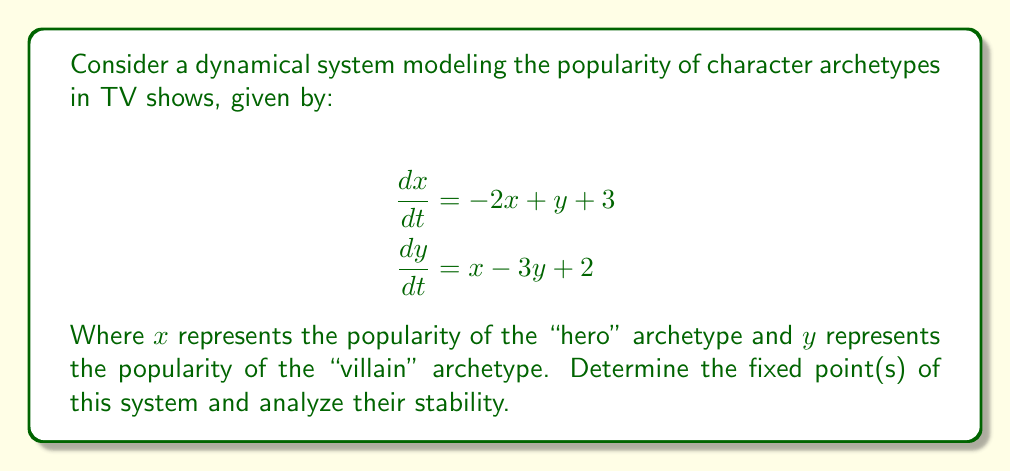Show me your answer to this math problem. 1. To find the fixed points, set both equations equal to zero:
   $$-2x + y + 3 = 0$$
   $$x - 3y + 2 = 0$$

2. Solve this system of equations:
   From the second equation: $x = 3y - 2$
   Substitute into the first equation:
   $$-2(3y - 2) + y + 3 = 0$$
   $$-6y + 4 + y + 3 = 0$$
   $$-5y + 7 = 0$$
   $$y = \frac{7}{5}$$

   Substitute back to find $x$:
   $$x = 3(\frac{7}{5}) - 2 = \frac{11}{5}$$

   The fixed point is $(\frac{11}{5}, \frac{7}{5})$

3. To analyze stability, we need to find the Jacobian matrix:
   $$J = \begin{bmatrix}
   \frac{\partial f_1}{\partial x} & \frac{\partial f_1}{\partial y} \\
   \frac{\partial f_2}{\partial x} & \frac{\partial f_2}{\partial y}
   \end{bmatrix} = \begin{bmatrix}
   -2 & 1 \\
   1 & -3
   \end{bmatrix}$$

4. Calculate the eigenvalues of J:
   $$det(J - \lambda I) = \begin{vmatrix}
   -2-\lambda & 1 \\
   1 & -3-\lambda
   \end{vmatrix} = 0$$
   
   $$(-2-\lambda)(-3-\lambda) - 1 = 0$$
   $$\lambda^2 + 5\lambda + 5 = 0$$

5. Solve the characteristic equation:
   $$\lambda = \frac{-5 \pm \sqrt{25 - 20}}{2} = \frac{-5 \pm \sqrt{5}}{2}$$

   Both eigenvalues have negative real parts.

6. Since both eigenvalues have negative real parts, the fixed point is asymptotically stable.
Answer: The system has one asymptotically stable fixed point at $(\frac{11}{5}, \frac{7}{5})$. 